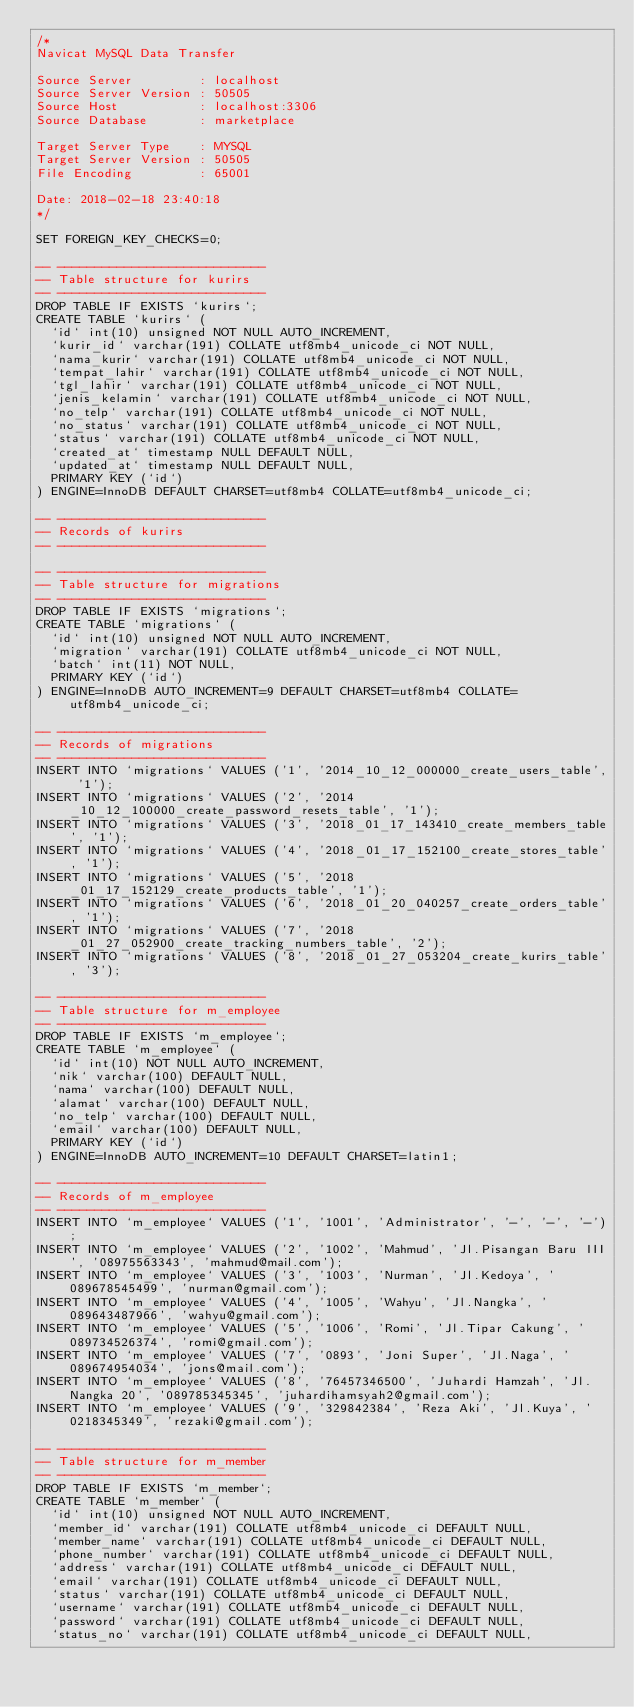Convert code to text. <code><loc_0><loc_0><loc_500><loc_500><_SQL_>/*
Navicat MySQL Data Transfer

Source Server         : localhost
Source Server Version : 50505
Source Host           : localhost:3306
Source Database       : marketplace

Target Server Type    : MYSQL
Target Server Version : 50505
File Encoding         : 65001

Date: 2018-02-18 23:40:18
*/

SET FOREIGN_KEY_CHECKS=0;

-- ----------------------------
-- Table structure for kurirs
-- ----------------------------
DROP TABLE IF EXISTS `kurirs`;
CREATE TABLE `kurirs` (
  `id` int(10) unsigned NOT NULL AUTO_INCREMENT,
  `kurir_id` varchar(191) COLLATE utf8mb4_unicode_ci NOT NULL,
  `nama_kurir` varchar(191) COLLATE utf8mb4_unicode_ci NOT NULL,
  `tempat_lahir` varchar(191) COLLATE utf8mb4_unicode_ci NOT NULL,
  `tgl_lahir` varchar(191) COLLATE utf8mb4_unicode_ci NOT NULL,
  `jenis_kelamin` varchar(191) COLLATE utf8mb4_unicode_ci NOT NULL,
  `no_telp` varchar(191) COLLATE utf8mb4_unicode_ci NOT NULL,
  `no_status` varchar(191) COLLATE utf8mb4_unicode_ci NOT NULL,
  `status` varchar(191) COLLATE utf8mb4_unicode_ci NOT NULL,
  `created_at` timestamp NULL DEFAULT NULL,
  `updated_at` timestamp NULL DEFAULT NULL,
  PRIMARY KEY (`id`)
) ENGINE=InnoDB DEFAULT CHARSET=utf8mb4 COLLATE=utf8mb4_unicode_ci;

-- ----------------------------
-- Records of kurirs
-- ----------------------------

-- ----------------------------
-- Table structure for migrations
-- ----------------------------
DROP TABLE IF EXISTS `migrations`;
CREATE TABLE `migrations` (
  `id` int(10) unsigned NOT NULL AUTO_INCREMENT,
  `migration` varchar(191) COLLATE utf8mb4_unicode_ci NOT NULL,
  `batch` int(11) NOT NULL,
  PRIMARY KEY (`id`)
) ENGINE=InnoDB AUTO_INCREMENT=9 DEFAULT CHARSET=utf8mb4 COLLATE=utf8mb4_unicode_ci;

-- ----------------------------
-- Records of migrations
-- ----------------------------
INSERT INTO `migrations` VALUES ('1', '2014_10_12_000000_create_users_table', '1');
INSERT INTO `migrations` VALUES ('2', '2014_10_12_100000_create_password_resets_table', '1');
INSERT INTO `migrations` VALUES ('3', '2018_01_17_143410_create_members_table', '1');
INSERT INTO `migrations` VALUES ('4', '2018_01_17_152100_create_stores_table', '1');
INSERT INTO `migrations` VALUES ('5', '2018_01_17_152129_create_products_table', '1');
INSERT INTO `migrations` VALUES ('6', '2018_01_20_040257_create_orders_table', '1');
INSERT INTO `migrations` VALUES ('7', '2018_01_27_052900_create_tracking_numbers_table', '2');
INSERT INTO `migrations` VALUES ('8', '2018_01_27_053204_create_kurirs_table', '3');

-- ----------------------------
-- Table structure for m_employee
-- ----------------------------
DROP TABLE IF EXISTS `m_employee`;
CREATE TABLE `m_employee` (
  `id` int(10) NOT NULL AUTO_INCREMENT,
  `nik` varchar(100) DEFAULT NULL,
  `nama` varchar(100) DEFAULT NULL,
  `alamat` varchar(100) DEFAULT NULL,
  `no_telp` varchar(100) DEFAULT NULL,
  `email` varchar(100) DEFAULT NULL,
  PRIMARY KEY (`id`)
) ENGINE=InnoDB AUTO_INCREMENT=10 DEFAULT CHARSET=latin1;

-- ----------------------------
-- Records of m_employee
-- ----------------------------
INSERT INTO `m_employee` VALUES ('1', '1001', 'Administrator', '-', '-', '-');
INSERT INTO `m_employee` VALUES ('2', '1002', 'Mahmud', 'Jl.Pisangan Baru III', '08975563343', 'mahmud@mail.com');
INSERT INTO `m_employee` VALUES ('3', '1003', 'Nurman', 'Jl.Kedoya', '089678545499', 'nurman@gmail.com');
INSERT INTO `m_employee` VALUES ('4', '1005', 'Wahyu', 'Jl.Nangka', '089643487966', 'wahyu@gmail.com');
INSERT INTO `m_employee` VALUES ('5', '1006', 'Romi', 'Jl.Tipar Cakung', '089734526374', 'romi@gmail.com');
INSERT INTO `m_employee` VALUES ('7', '0893', 'Joni Super', 'Jl.Naga', '089674954034', 'jons@mail.com');
INSERT INTO `m_employee` VALUES ('8', '76457346500', 'Juhardi Hamzah', 'Jl.Nangka 20', '089785345345', 'juhardihamsyah2@gmail.com');
INSERT INTO `m_employee` VALUES ('9', '329842384', 'Reza Aki', 'Jl.Kuya', '0218345349', 'rezaki@gmail.com');

-- ----------------------------
-- Table structure for m_member
-- ----------------------------
DROP TABLE IF EXISTS `m_member`;
CREATE TABLE `m_member` (
  `id` int(10) unsigned NOT NULL AUTO_INCREMENT,
  `member_id` varchar(191) COLLATE utf8mb4_unicode_ci DEFAULT NULL,
  `member_name` varchar(191) COLLATE utf8mb4_unicode_ci DEFAULT NULL,
  `phone_number` varchar(191) COLLATE utf8mb4_unicode_ci DEFAULT NULL,
  `address` varchar(191) COLLATE utf8mb4_unicode_ci DEFAULT NULL,
  `email` varchar(191) COLLATE utf8mb4_unicode_ci DEFAULT NULL,
  `status` varchar(191) COLLATE utf8mb4_unicode_ci DEFAULT NULL,
  `username` varchar(191) COLLATE utf8mb4_unicode_ci DEFAULT NULL,
  `password` varchar(191) COLLATE utf8mb4_unicode_ci DEFAULT NULL,
  `status_no` varchar(191) COLLATE utf8mb4_unicode_ci DEFAULT NULL,</code> 